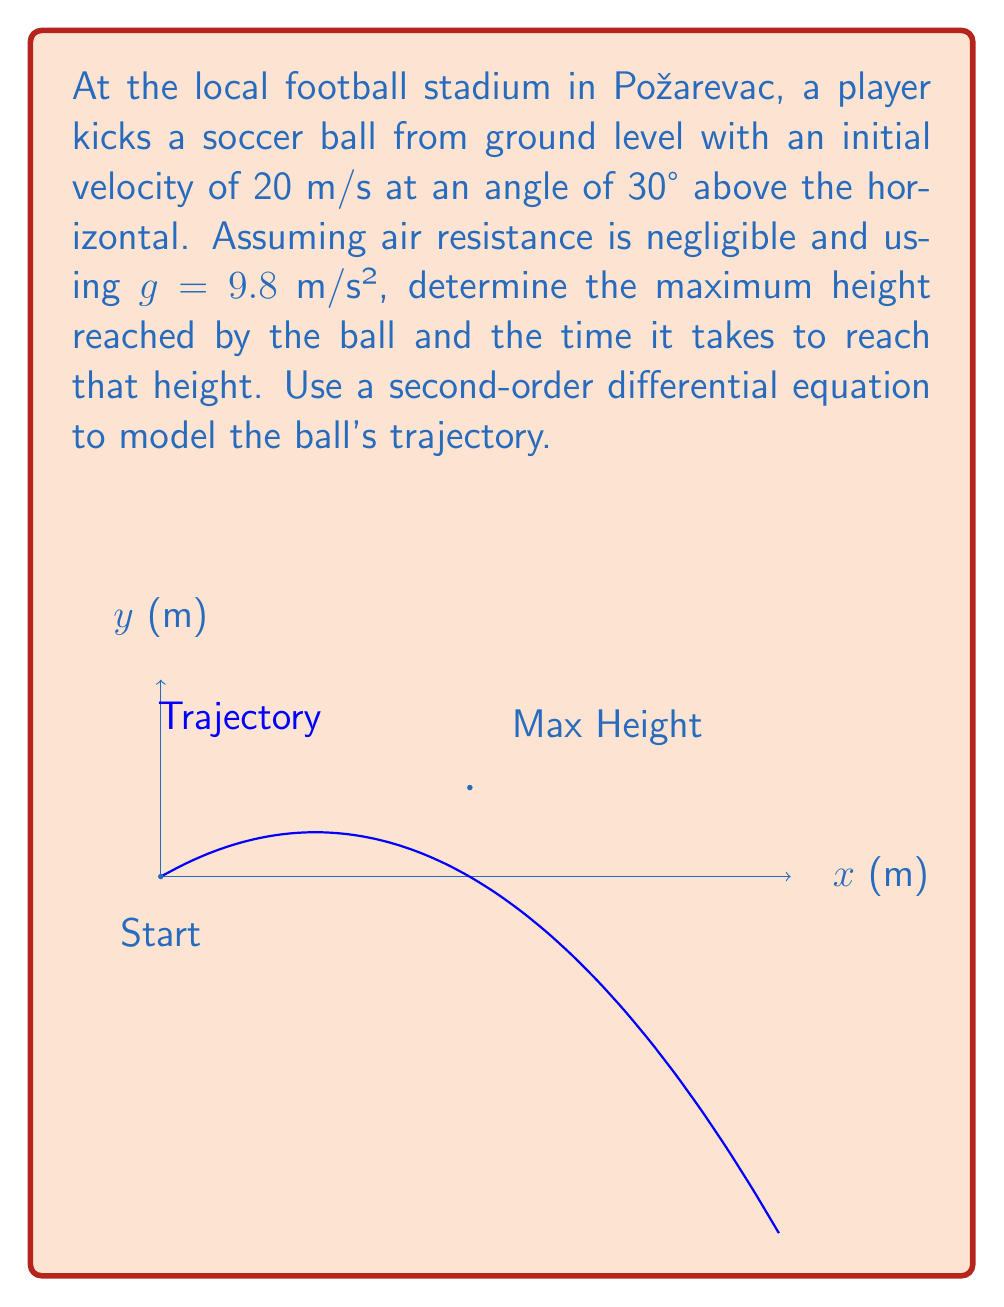Solve this math problem. Let's approach this problem step-by-step:

1) The second-order differential equation for the trajectory of a projectile is:

   $$\frac{d^2y}{dt^2} = -g$$

   where $g$ is the acceleration due to gravity (9.8 m/s²).

2) We can integrate this equation twice to get the position equations:

   $$\frac{dy}{dt} = -gt + v_0\sin\theta$$
   $$y = -\frac{1}{2}gt^2 + (v_0\sin\theta)t + y_0$$

   where $v_0$ is the initial velocity, $\theta$ is the launch angle, and $y_0$ is the initial height.

3) Given:
   $v_0 = 20$ m/s
   $\theta = 30°$
   $y_0 = 0$ m

4) The vertical component of the initial velocity is:
   $$v_0\sin\theta = 20 \sin(30°) = 10$ m/s$$

5) So our equation for height is:
   $$y = -4.9t^2 + 10t$$

6) To find the maximum height, we need to find when the vertical velocity is zero:
   $$\frac{dy}{dt} = -9.8t + 10 = 0$$
   $$t = \frac{10}{9.8} \approx 1.02$ s$$

7) Plugging this time back into our height equation:
   $$y_{max} = -4.9(1.02)^2 + 10(1.02) \approx 5.1$ m$$

Therefore, the maximum height is approximately 5.1 meters, reached after about 1.02 seconds.
Answer: Maximum height: 5.1 m; Time to reach maximum height: 1.02 s 